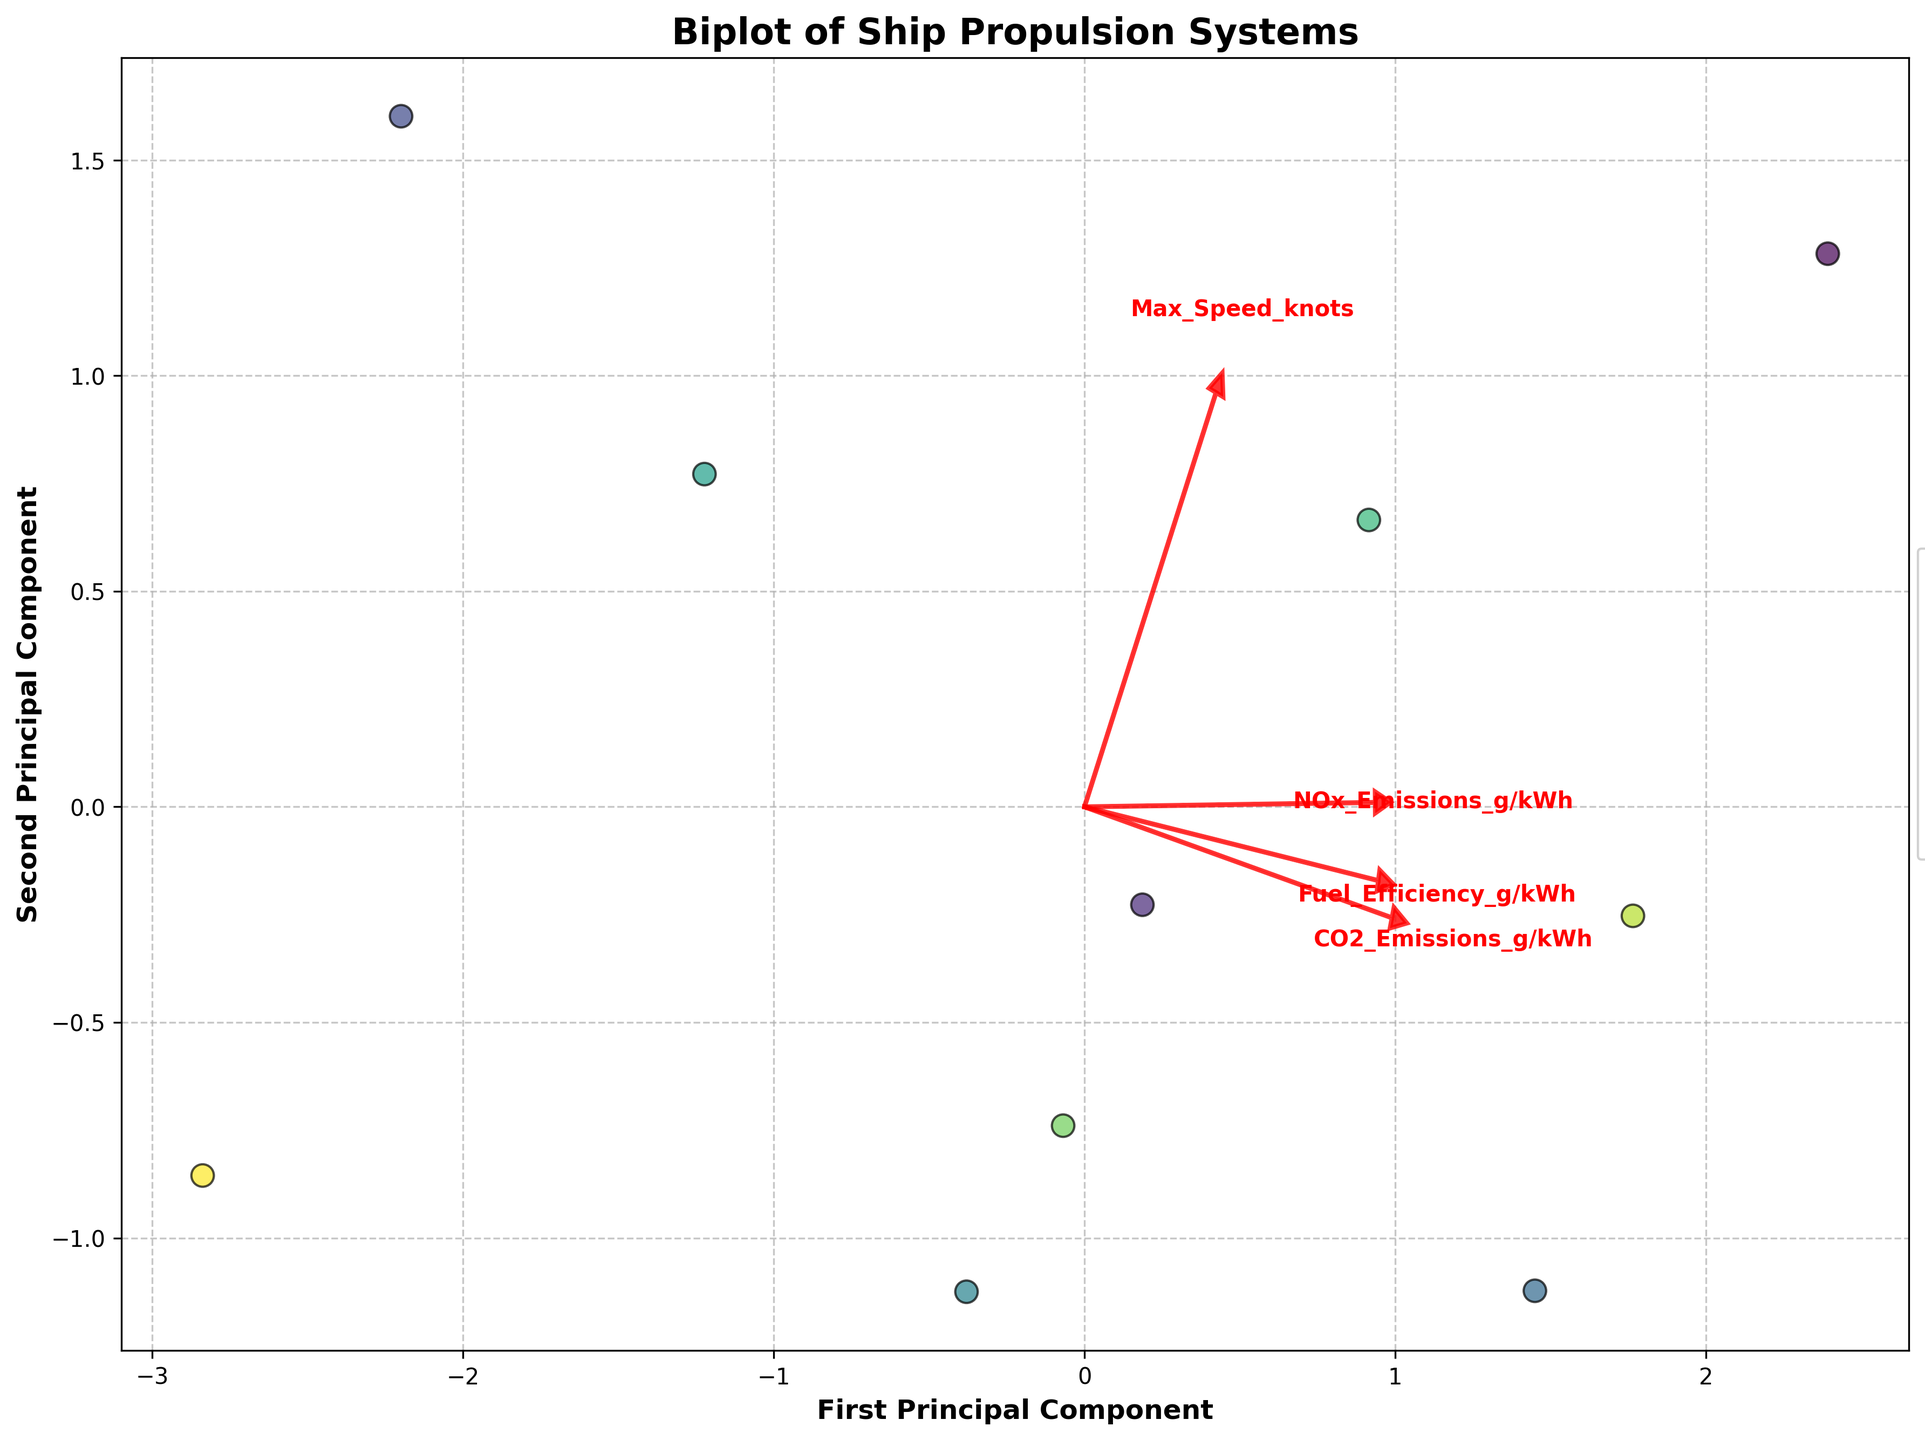What is the title of the figure? The title of the figure can be found at the top of the chart and usually describes what the plot represents.
Answer: Biplot of Ship Propulsion Systems How many ship propulsion systems are represented in the plot? Each data point on the scatter plot represents a different ship type. By counting all the data points, we can determine how many ship propulsion systems are included.
Answer: 10 Which ship propulsion system is closest to the origin? The origin (0,0) on the plot represents the average in terms of the first and second principal components. The ship type closest to this point should be easily identifiable by visual comparison.
Answer: Methanol Powered Cruise Ship Which feature has the most prominent loading vector in terms of length? The length of the loading vector (arrow) indicates the influence of a feature on the principal components. The longest arrow corresponds to the most prominent feature.
Answer: CO2 Emissions (g/kWh) What are the two principal components used in the plot? The principal components are usually labeled on the axes. The x-axis represents the first principal component, and the y-axis represents the second principal component.
Answer: First Principal Component and Second Principal Component Which ship type has the highest value in the first principal component? By examining the data points along the x-axis, the ship type that is farthest to the right has the highest value in the first principal component.
Answer: Diesel Engine Containership Which ship types do not contribute to CO2 emissions? The loading vector for CO2 Emissions can be evaluated in conjunction with the ship types that are found near the negative or null points for this vector.
Answer: Nuclear Powered Icebreaker, Hydrogen Fuel Cell Ro-Ro, Solar Electric Catamaran How do the loadings of Fuel Efficiency and NOx Emissions compare? To answer this, we need to analyze the angles and lengths of the loading vectors for both Fuel Efficiency and NOx Emissions. A smaller angle and nearly equal length indicate a correlation.
Answer: Both loadings are somewhat aligned but differ in length Which ship propulsion system is most similar to the Wind Assisted Tanker in terms of principal components? By comparing the proximity of data points of different ship types, we can identify the ship type closest to the Wind Assisted Tanker's coordinates.
Answer: Ammonia Powered VLCC 